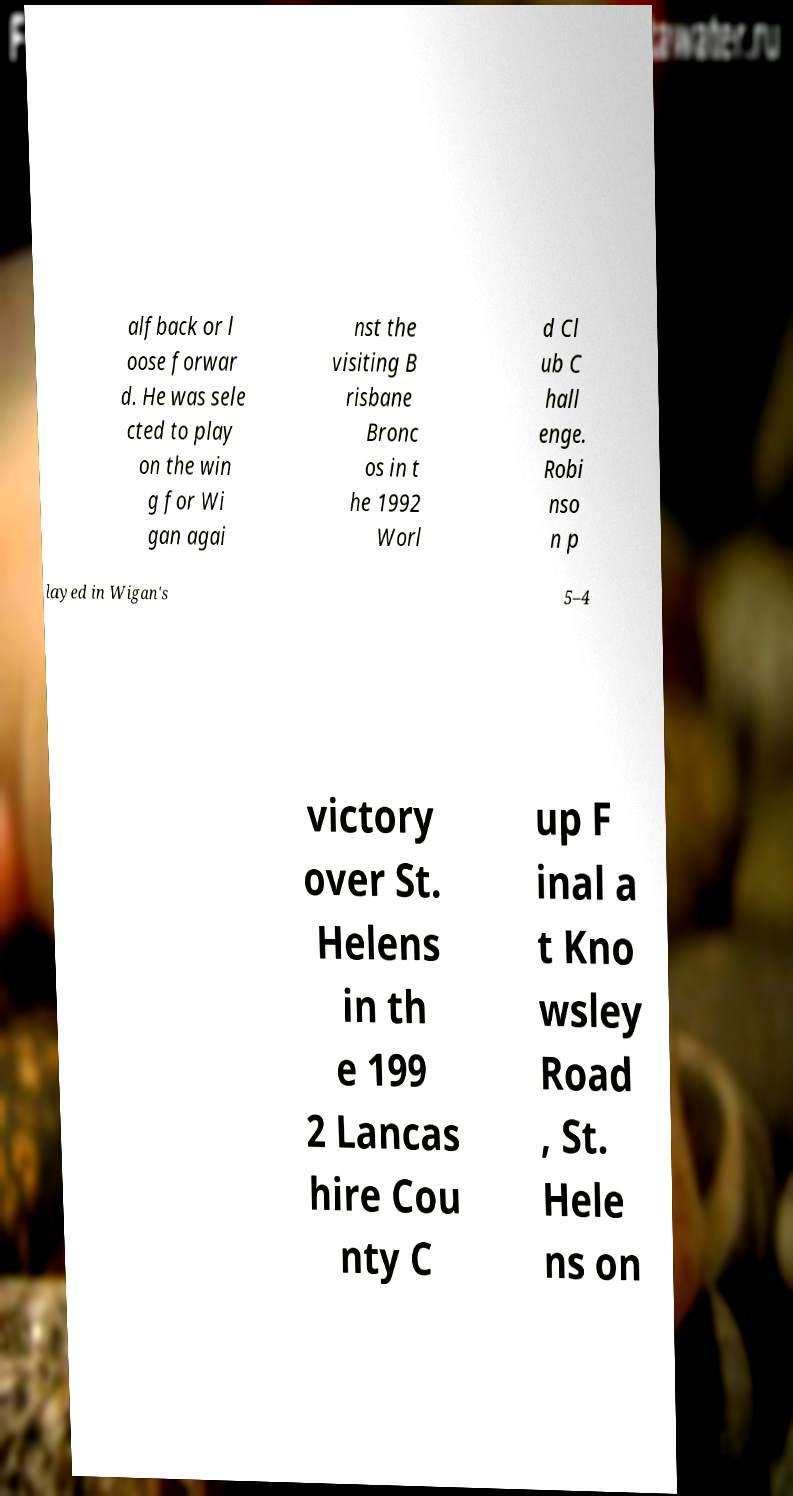Could you assist in decoding the text presented in this image and type it out clearly? alfback or l oose forwar d. He was sele cted to play on the win g for Wi gan agai nst the visiting B risbane Bronc os in t he 1992 Worl d Cl ub C hall enge. Robi nso n p layed in Wigan's 5–4 victory over St. Helens in th e 199 2 Lancas hire Cou nty C up F inal a t Kno wsley Road , St. Hele ns on 